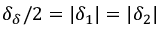Convert formula to latex. <formula><loc_0><loc_0><loc_500><loc_500>\delta _ { \delta } / 2 = | \delta _ { 1 } | = | \delta _ { 2 } |</formula> 